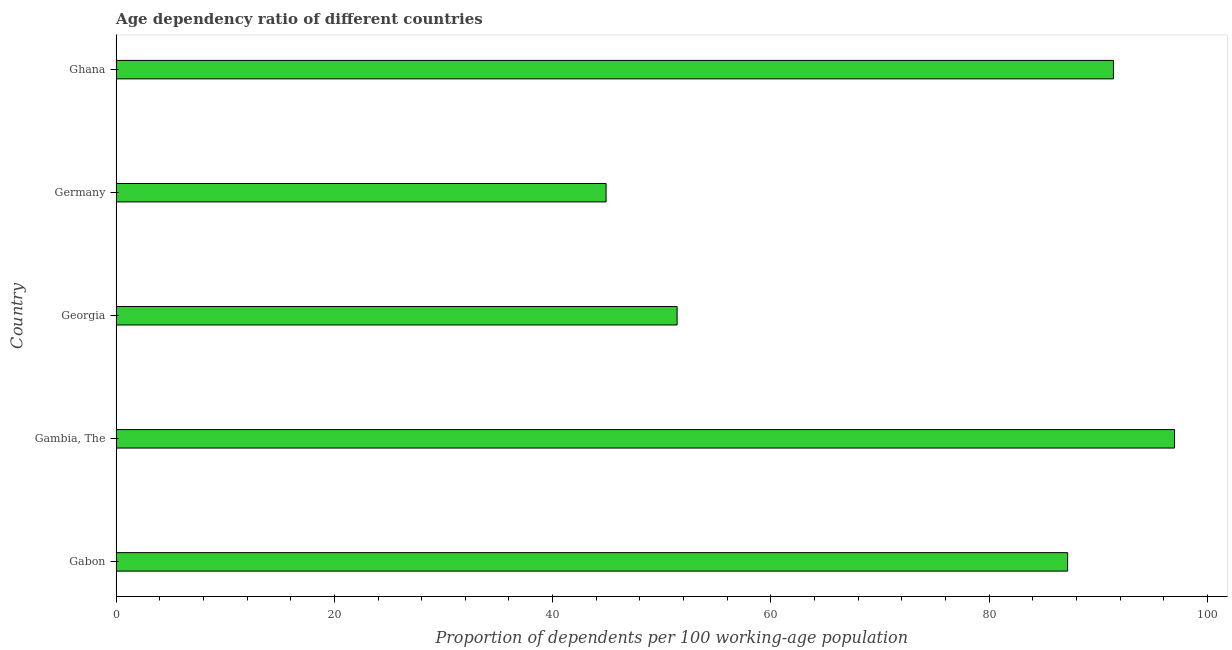What is the title of the graph?
Your answer should be very brief. Age dependency ratio of different countries. What is the label or title of the X-axis?
Give a very brief answer. Proportion of dependents per 100 working-age population. What is the label or title of the Y-axis?
Give a very brief answer. Country. What is the age dependency ratio in Germany?
Ensure brevity in your answer.  44.9. Across all countries, what is the maximum age dependency ratio?
Make the answer very short. 97. Across all countries, what is the minimum age dependency ratio?
Your answer should be compact. 44.9. In which country was the age dependency ratio maximum?
Provide a short and direct response. Gambia, The. What is the sum of the age dependency ratio?
Give a very brief answer. 371.91. What is the difference between the age dependency ratio in Georgia and Ghana?
Provide a succinct answer. -39.99. What is the average age dependency ratio per country?
Your answer should be compact. 74.38. What is the median age dependency ratio?
Provide a short and direct response. 87.2. In how many countries, is the age dependency ratio greater than 24 ?
Provide a succinct answer. 5. What is the ratio of the age dependency ratio in Gambia, The to that in Georgia?
Ensure brevity in your answer.  1.89. Is the difference between the age dependency ratio in Georgia and Ghana greater than the difference between any two countries?
Provide a short and direct response. No. What is the difference between the highest and the second highest age dependency ratio?
Your response must be concise. 5.6. Is the sum of the age dependency ratio in Gabon and Ghana greater than the maximum age dependency ratio across all countries?
Give a very brief answer. Yes. What is the difference between the highest and the lowest age dependency ratio?
Keep it short and to the point. 52.1. Are all the bars in the graph horizontal?
Provide a short and direct response. Yes. How many countries are there in the graph?
Offer a very short reply. 5. What is the Proportion of dependents per 100 working-age population in Gabon?
Offer a very short reply. 87.2. What is the Proportion of dependents per 100 working-age population in Gambia, The?
Offer a very short reply. 97. What is the Proportion of dependents per 100 working-age population in Georgia?
Your response must be concise. 51.41. What is the Proportion of dependents per 100 working-age population of Germany?
Give a very brief answer. 44.9. What is the Proportion of dependents per 100 working-age population of Ghana?
Give a very brief answer. 91.4. What is the difference between the Proportion of dependents per 100 working-age population in Gabon and Gambia, The?
Provide a short and direct response. -9.8. What is the difference between the Proportion of dependents per 100 working-age population in Gabon and Georgia?
Make the answer very short. 35.79. What is the difference between the Proportion of dependents per 100 working-age population in Gabon and Germany?
Your answer should be compact. 42.3. What is the difference between the Proportion of dependents per 100 working-age population in Gabon and Ghana?
Offer a very short reply. -4.2. What is the difference between the Proportion of dependents per 100 working-age population in Gambia, The and Georgia?
Offer a very short reply. 45.59. What is the difference between the Proportion of dependents per 100 working-age population in Gambia, The and Germany?
Provide a short and direct response. 52.1. What is the difference between the Proportion of dependents per 100 working-age population in Gambia, The and Ghana?
Your answer should be compact. 5.6. What is the difference between the Proportion of dependents per 100 working-age population in Georgia and Germany?
Make the answer very short. 6.51. What is the difference between the Proportion of dependents per 100 working-age population in Georgia and Ghana?
Your answer should be compact. -39.99. What is the difference between the Proportion of dependents per 100 working-age population in Germany and Ghana?
Offer a very short reply. -46.5. What is the ratio of the Proportion of dependents per 100 working-age population in Gabon to that in Gambia, The?
Ensure brevity in your answer.  0.9. What is the ratio of the Proportion of dependents per 100 working-age population in Gabon to that in Georgia?
Your answer should be very brief. 1.7. What is the ratio of the Proportion of dependents per 100 working-age population in Gabon to that in Germany?
Your answer should be compact. 1.94. What is the ratio of the Proportion of dependents per 100 working-age population in Gabon to that in Ghana?
Provide a succinct answer. 0.95. What is the ratio of the Proportion of dependents per 100 working-age population in Gambia, The to that in Georgia?
Your response must be concise. 1.89. What is the ratio of the Proportion of dependents per 100 working-age population in Gambia, The to that in Germany?
Give a very brief answer. 2.16. What is the ratio of the Proportion of dependents per 100 working-age population in Gambia, The to that in Ghana?
Keep it short and to the point. 1.06. What is the ratio of the Proportion of dependents per 100 working-age population in Georgia to that in Germany?
Give a very brief answer. 1.15. What is the ratio of the Proportion of dependents per 100 working-age population in Georgia to that in Ghana?
Offer a terse response. 0.56. What is the ratio of the Proportion of dependents per 100 working-age population in Germany to that in Ghana?
Give a very brief answer. 0.49. 